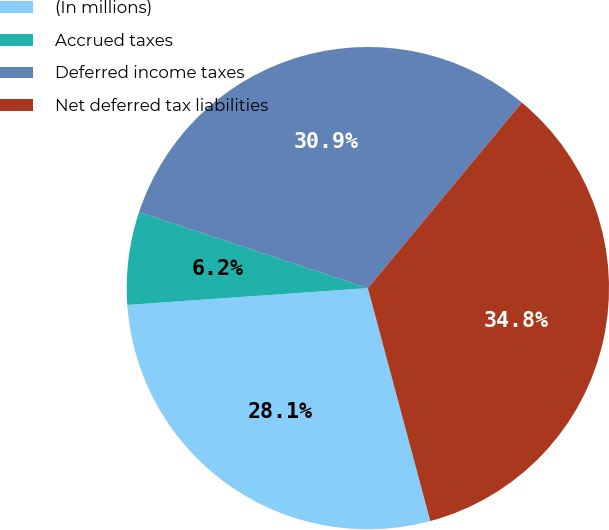<chart> <loc_0><loc_0><loc_500><loc_500><pie_chart><fcel>(In millions)<fcel>Accrued taxes<fcel>Deferred income taxes<fcel>Net deferred tax liabilities<nl><fcel>28.06%<fcel>6.22%<fcel>30.92%<fcel>34.81%<nl></chart> 